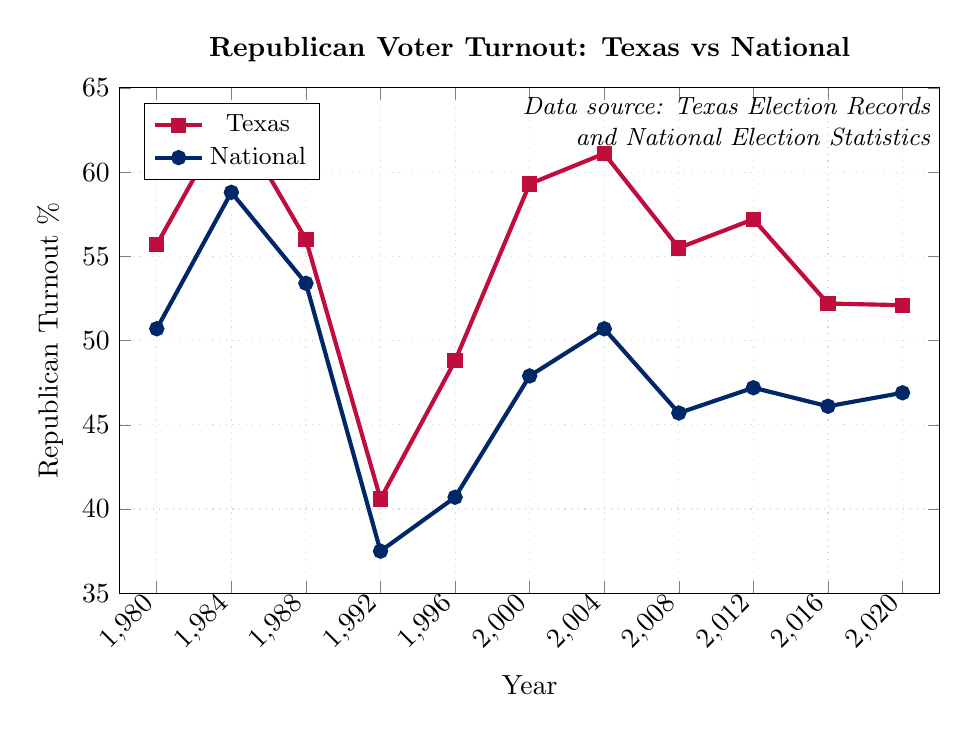Which year had the highest Republican voter turnout percentage in Texas? Look at the Texas Republican turnout line. The highest point appears in 1984.
Answer: 1984 How does the Texas Republican voter turnout percentage in 2008 compare to the national average in the same year? Check the year 2008 on both the Texas and National lines. Texas is at 55.5% while the national average is 45.7%. Texas is higher by 9.8%.
Answer: Higher by 9.8% What is the average Republican voter turnout percentage in Texas for the years 1996, 2000, and 2004? Add the percentages for Texas in 1996 (48.8%), 2000 (59.3%), and 2004 (61.1%) and divide by 3. The sum is 169.2%, so the average is 169.2 / 3.
Answer: 56.4% Between 1980 and 2020, which had a greater range of Republican voter turnout percentages: Texas or the national average? Find the difference between the highest and lowest turnout percentages for both Texas and the national average. Texas: 63.6% - 40.6% = 23.0%. National: 58.8% - 37.5% = 21.3%. Texas has a greater range.
Answer: Texas In which year did the national Republican turnout percentage exceed Texas' turnout percentage? Look for years where the National line is higher than the Texas line. There are no years where the national turnout exceeds Texas'.
Answer: None By what percentage did the Texas Republican voter turnout drop between 2012 and 2016? Texas turnout in 2012 was 57.2% and in 2016 it was 52.2%. The drop is 57.2% - 52.2% = 5.0%.
Answer: 5.0% What is the median national Republican voter turnout percentage over the years shown? Arrange the national percentages in ascending order: 37.5%, 40.7%, 45.7%, 46.1%, 46.9%, 47.2%, 47.9%, 50.7%, 50.7%, 53.4%, 58.8%. The median is the middle value, which is 47.2%.
Answer: 47.2% Looking at the visual attributes, which line represents the Texas Republican turnout? The Texas line is represented by red with square markers, as indicated in the legend.
Answer: Red with square markers How many years saw a Republican voter turnout percentage in Texas higher than 60%? Count the years in Texas' data where the percentage is above 60%. These years are 1984, 2000, and 2004, totalling three years.
Answer: 3 